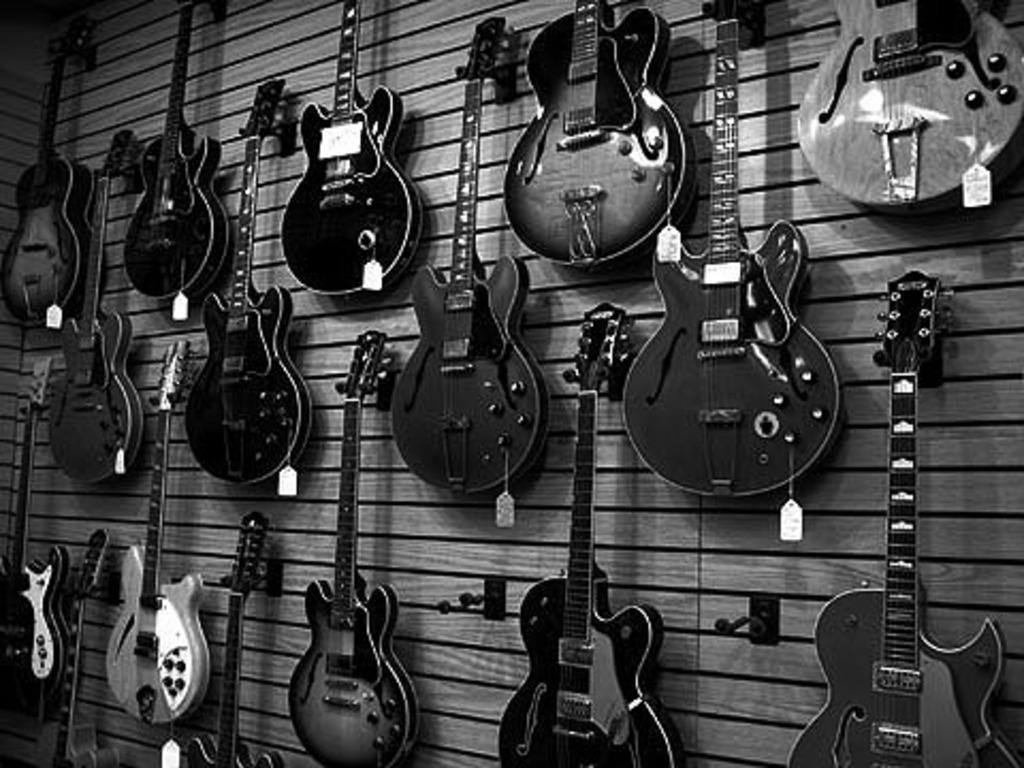What is present on the wall in the image? There are musical instruments placed on the wall in the image. What additional information can be gathered about the musical instruments? Each musical instrument has a rate tag. How do the rate tags differ from one another? The rate tags have different colors, shapes, and sizes. Can you tell me how many loaves of bread are on the wall in the image? There are no loaves of bread present in the image; it features musical instruments with rate tags on the wall. What type of war is being depicted in the image? There is no depiction of a war in the image; it features musical instruments with rate tags on the wall. 